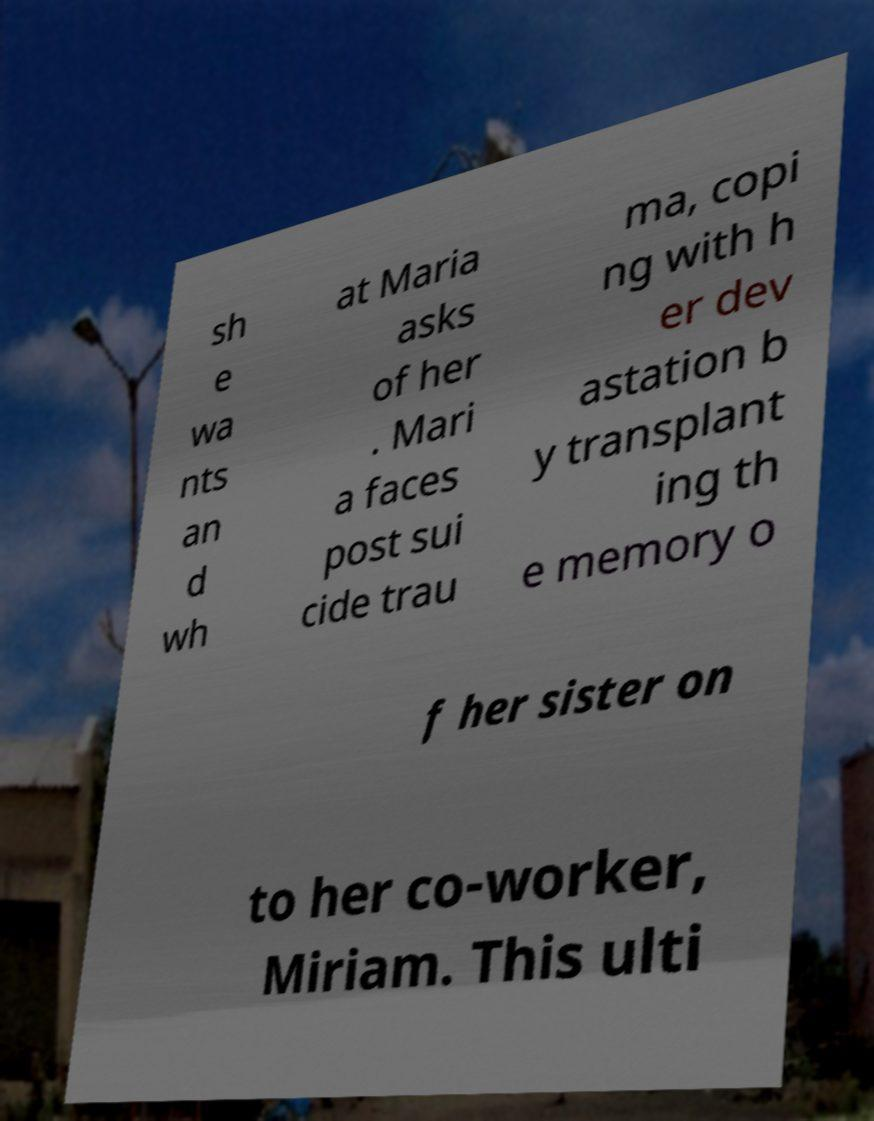Could you extract and type out the text from this image? sh e wa nts an d wh at Maria asks of her . Mari a faces post sui cide trau ma, copi ng with h er dev astation b y transplant ing th e memory o f her sister on to her co-worker, Miriam. This ulti 